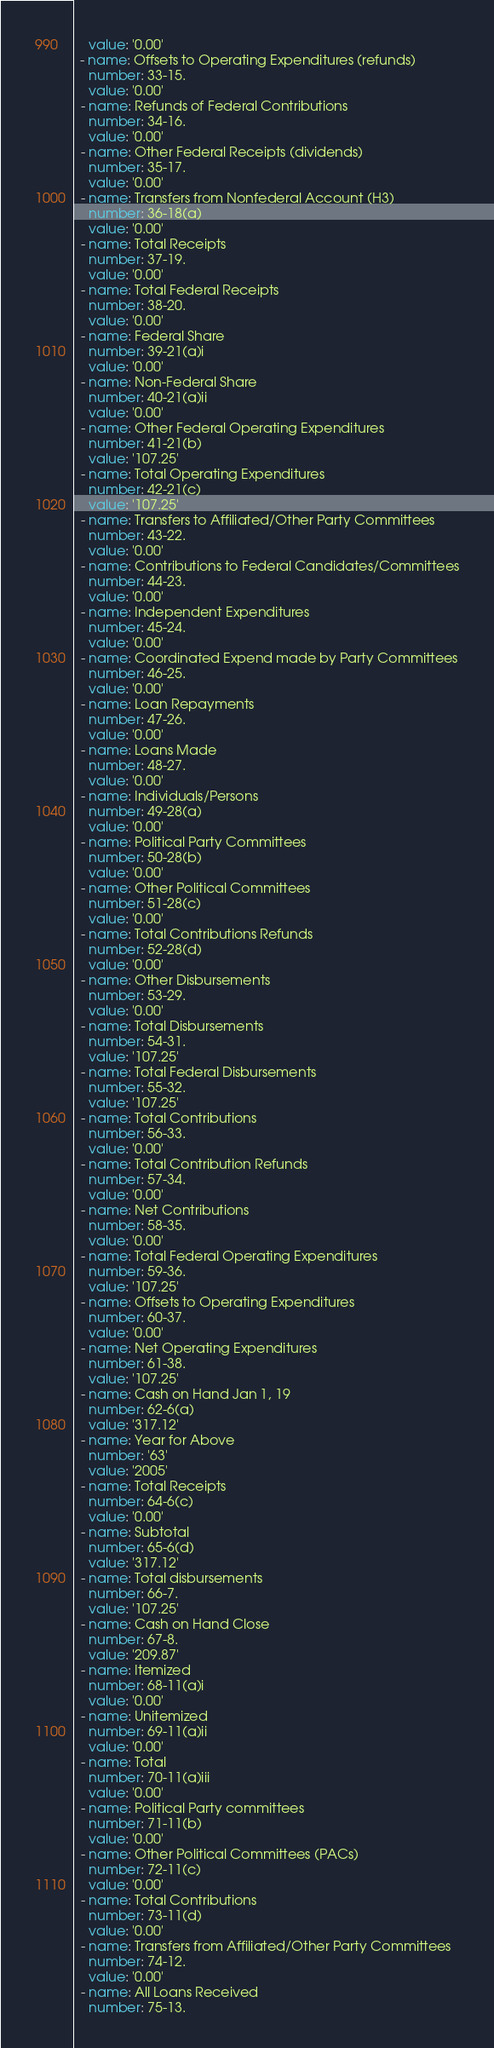Convert code to text. <code><loc_0><loc_0><loc_500><loc_500><_YAML_>    value: '0.00'
  - name: Offsets to Operating Expenditures (refunds)
    number: 33-15.
    value: '0.00'
  - name: Refunds of Federal Contributions
    number: 34-16.
    value: '0.00'
  - name: Other Federal Receipts (dividends)
    number: 35-17.
    value: '0.00'
  - name: Transfers from Nonfederal Account (H3)
    number: 36-18(a)
    value: '0.00'
  - name: Total Receipts
    number: 37-19.
    value: '0.00'
  - name: Total Federal Receipts
    number: 38-20.
    value: '0.00'
  - name: Federal Share
    number: 39-21(a)i
    value: '0.00'
  - name: Non-Federal Share
    number: 40-21(a)ii
    value: '0.00'
  - name: Other Federal Operating Expenditures
    number: 41-21(b)
    value: '107.25'
  - name: Total Operating Expenditures
    number: 42-21(c)
    value: '107.25'
  - name: Transfers to Affiliated/Other Party Committees
    number: 43-22.
    value: '0.00'
  - name: Contributions to Federal Candidates/Committees
    number: 44-23.
    value: '0.00'
  - name: Independent Expenditures
    number: 45-24.
    value: '0.00'
  - name: Coordinated Expend made by Party Committees
    number: 46-25.
    value: '0.00'
  - name: Loan Repayments
    number: 47-26.
    value: '0.00'
  - name: Loans Made
    number: 48-27.
    value: '0.00'
  - name: Individuals/Persons
    number: 49-28(a)
    value: '0.00'
  - name: Political Party Committees
    number: 50-28(b)
    value: '0.00'
  - name: Other Political Committees
    number: 51-28(c)
    value: '0.00'
  - name: Total Contributions Refunds
    number: 52-28(d)
    value: '0.00'
  - name: Other Disbursements
    number: 53-29.
    value: '0.00'
  - name: Total Disbursements
    number: 54-31.
    value: '107.25'
  - name: Total Federal Disbursements
    number: 55-32.
    value: '107.25'
  - name: Total Contributions
    number: 56-33.
    value: '0.00'
  - name: Total Contribution Refunds
    number: 57-34.
    value: '0.00'
  - name: Net Contributions
    number: 58-35.
    value: '0.00'
  - name: Total Federal Operating Expenditures
    number: 59-36.
    value: '107.25'
  - name: Offsets to Operating Expenditures
    number: 60-37.
    value: '0.00'
  - name: Net Operating Expenditures
    number: 61-38.
    value: '107.25'
  - name: Cash on Hand Jan 1, 19
    number: 62-6(a)
    value: '317.12'
  - name: Year for Above
    number: '63'
    value: '2005'
  - name: Total Receipts
    number: 64-6(c)
    value: '0.00'
  - name: Subtotal
    number: 65-6(d)
    value: '317.12'
  - name: Total disbursements
    number: 66-7.
    value: '107.25'
  - name: Cash on Hand Close
    number: 67-8.
    value: '209.87'
  - name: Itemized
    number: 68-11(a)i
    value: '0.00'
  - name: Unitemized
    number: 69-11(a)ii
    value: '0.00'
  - name: Total
    number: 70-11(a)iii
    value: '0.00'
  - name: Political Party committees
    number: 71-11(b)
    value: '0.00'
  - name: Other Political Committees (PACs)
    number: 72-11(c)
    value: '0.00'
  - name: Total Contributions
    number: 73-11(d)
    value: '0.00'
  - name: Transfers from Affiliated/Other Party Committees
    number: 74-12.
    value: '0.00'
  - name: All Loans Received
    number: 75-13.</code> 